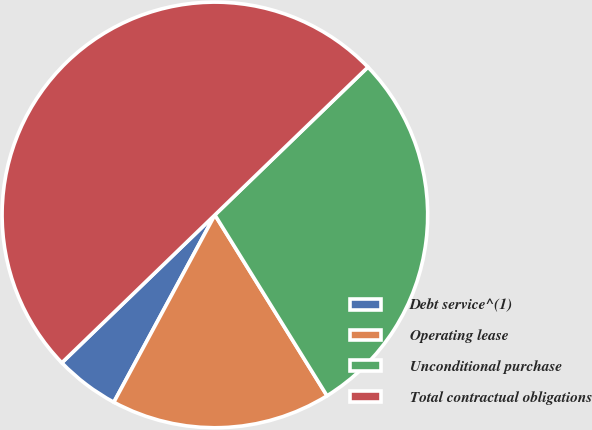Convert chart to OTSL. <chart><loc_0><loc_0><loc_500><loc_500><pie_chart><fcel>Debt service^(1)<fcel>Operating lease<fcel>Unconditional purchase<fcel>Total contractual obligations<nl><fcel>4.9%<fcel>16.71%<fcel>28.39%<fcel>50.0%<nl></chart> 